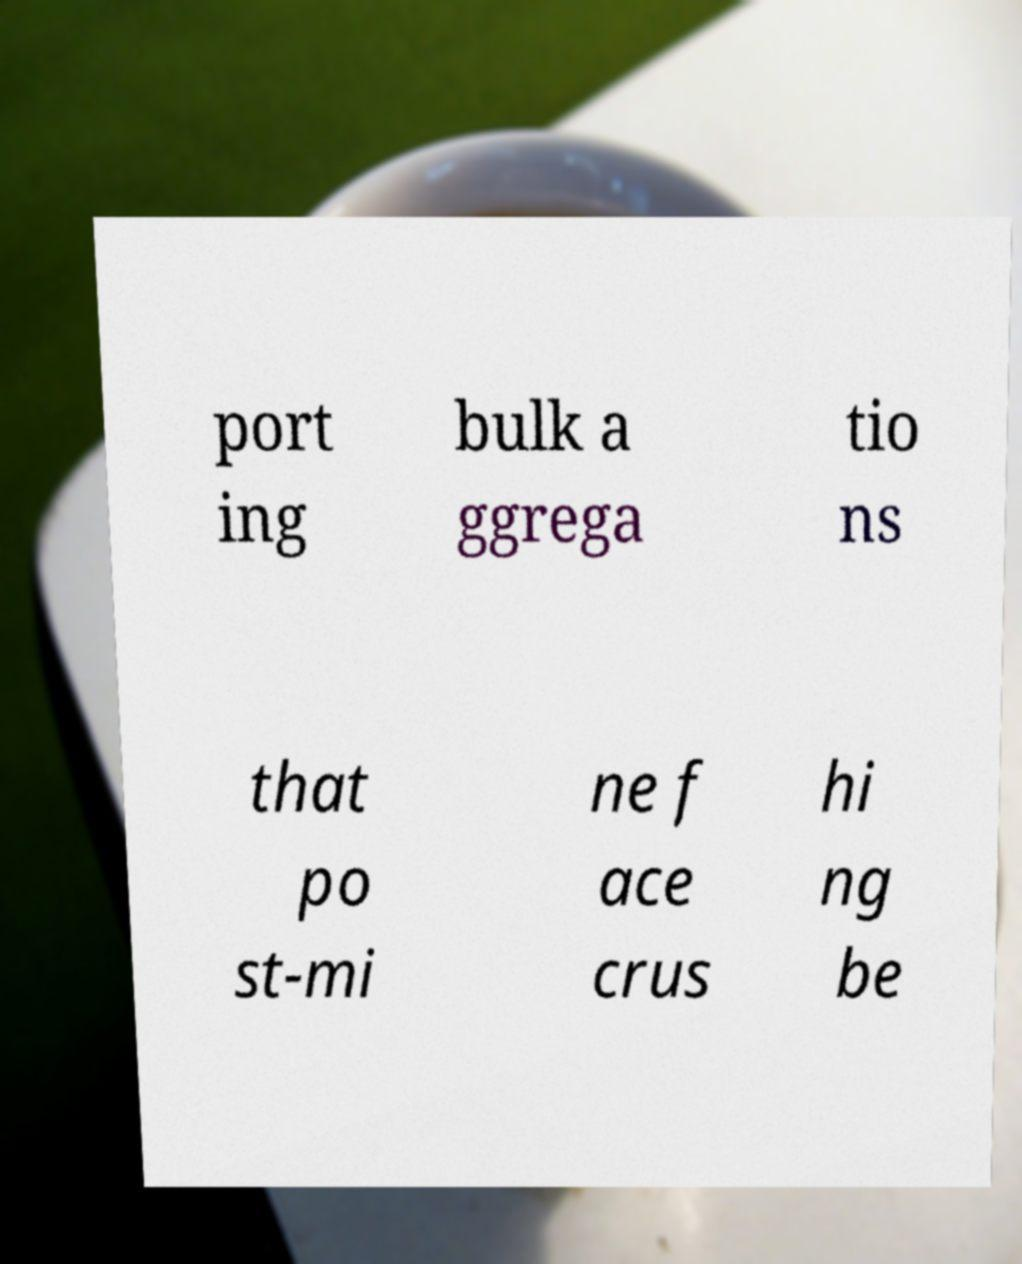What messages or text are displayed in this image? I need them in a readable, typed format. port ing bulk a ggrega tio ns that po st-mi ne f ace crus hi ng be 